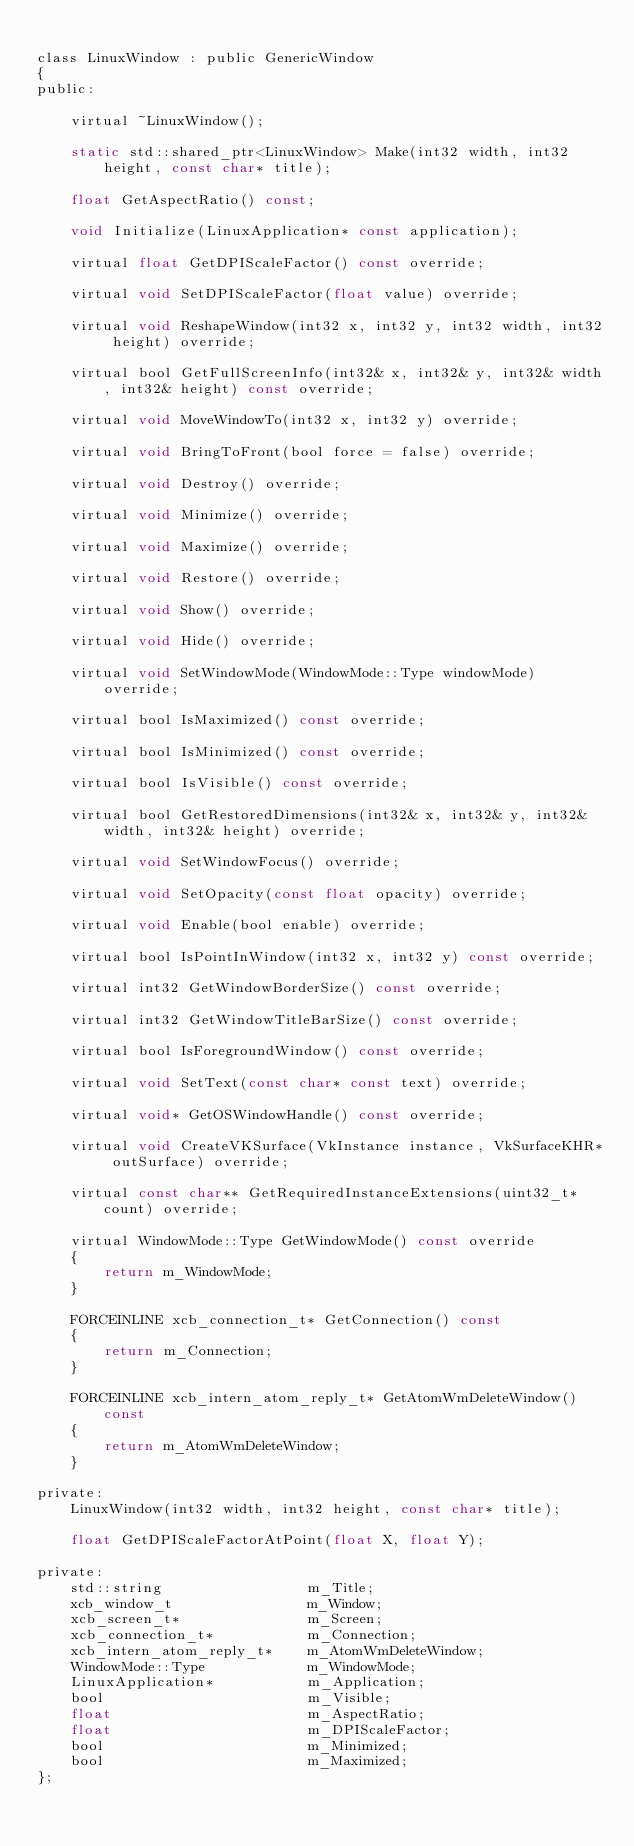Convert code to text. <code><loc_0><loc_0><loc_500><loc_500><_C_>
class LinuxWindow : public GenericWindow
{
public:

	virtual ~LinuxWindow();

	static std::shared_ptr<LinuxWindow> Make(int32 width, int32 height, const char* title);

	float GetAspectRatio() const;

	void Initialize(LinuxApplication* const application);

	virtual float GetDPIScaleFactor() const override;

	virtual void SetDPIScaleFactor(float value) override;

	virtual void ReshapeWindow(int32 x, int32 y, int32 width, int32 height) override;

	virtual bool GetFullScreenInfo(int32& x, int32& y, int32& width, int32& height) const override;

	virtual void MoveWindowTo(int32 x, int32 y) override;

	virtual void BringToFront(bool force = false) override;

	virtual void Destroy() override;

	virtual void Minimize() override;

	virtual void Maximize() override;

	virtual void Restore() override;

	virtual void Show() override;

	virtual void Hide() override;

	virtual void SetWindowMode(WindowMode::Type windowMode) override;

	virtual bool IsMaximized() const override;

	virtual bool IsMinimized() const override;

	virtual bool IsVisible() const override;

	virtual bool GetRestoredDimensions(int32& x, int32& y, int32& width, int32& height) override;

	virtual void SetWindowFocus() override;

	virtual void SetOpacity(const float opacity) override;

	virtual void Enable(bool enable) override;

	virtual bool IsPointInWindow(int32 x, int32 y) const override;

	virtual int32 GetWindowBorderSize() const override;

	virtual int32 GetWindowTitleBarSize() const override;

	virtual bool IsForegroundWindow() const override;

	virtual void SetText(const char* const text) override;

	virtual void* GetOSWindowHandle() const override;

	virtual void CreateVKSurface(VkInstance instance, VkSurfaceKHR* outSurface) override;

	virtual const char** GetRequiredInstanceExtensions(uint32_t* count) override;

	virtual WindowMode::Type GetWindowMode() const override
	{
		return m_WindowMode;
	}

	FORCEINLINE xcb_connection_t* GetConnection() const
	{
		return m_Connection;
	}

	FORCEINLINE xcb_intern_atom_reply_t* GetAtomWmDeleteWindow() const
	{
		return m_AtomWmDeleteWindow;
	}
	
private:
	LinuxWindow(int32 width, int32 height, const char* title);

	float GetDPIScaleFactorAtPoint(float X, float Y);

private:
	std::string 				m_Title;
	xcb_window_t				m_Window;
	xcb_screen_t*				m_Screen;
	xcb_connection_t*			m_Connection;
	xcb_intern_atom_reply_t* 	m_AtomWmDeleteWindow;
	WindowMode::Type 			m_WindowMode;
	LinuxApplication* 			m_Application;
	bool 						m_Visible;
	float 						m_AspectRatio;
	float 						m_DPIScaleFactor;
	bool 						m_Minimized;
	bool 						m_Maximized;
};
</code> 